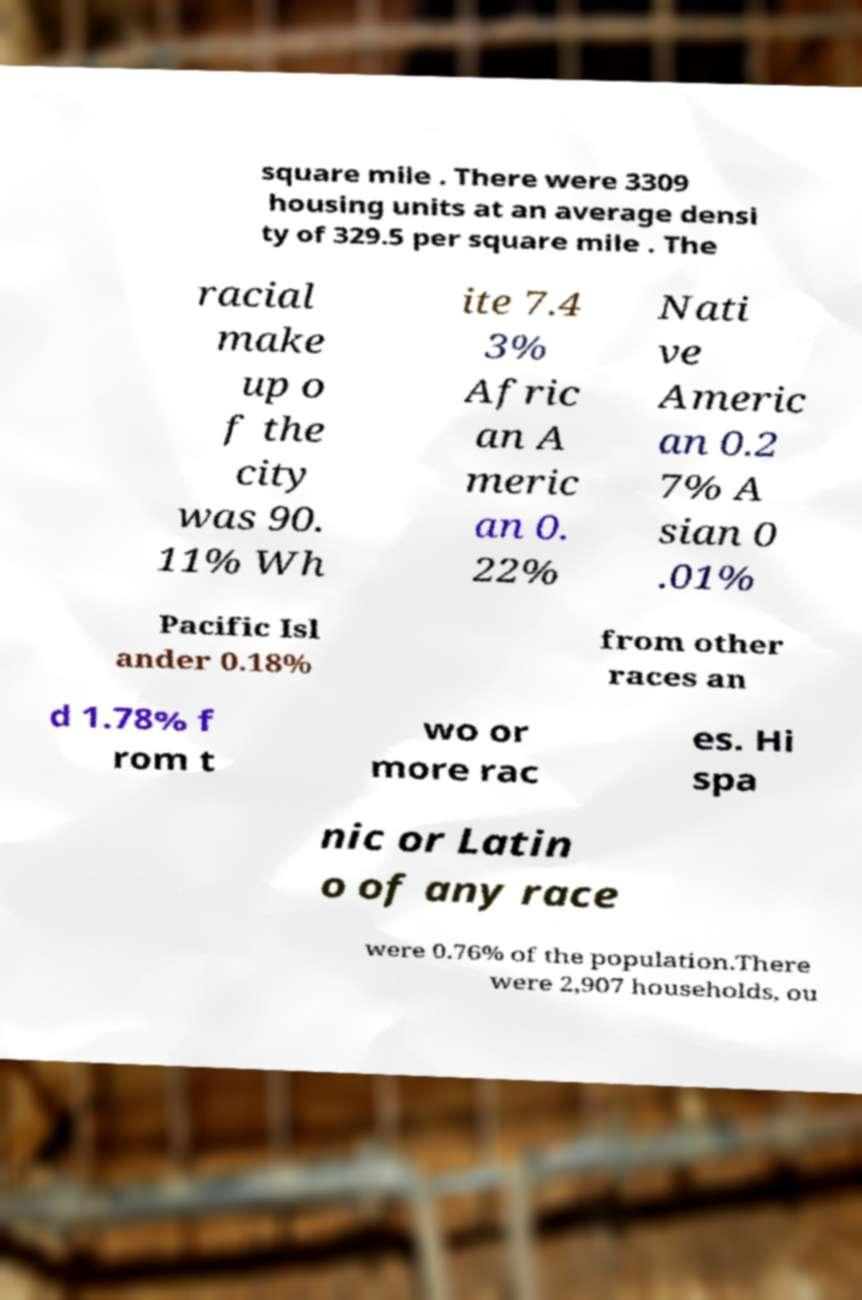Could you extract and type out the text from this image? square mile . There were 3309 housing units at an average densi ty of 329.5 per square mile . The racial make up o f the city was 90. 11% Wh ite 7.4 3% Afric an A meric an 0. 22% Nati ve Americ an 0.2 7% A sian 0 .01% Pacific Isl ander 0.18% from other races an d 1.78% f rom t wo or more rac es. Hi spa nic or Latin o of any race were 0.76% of the population.There were 2,907 households, ou 